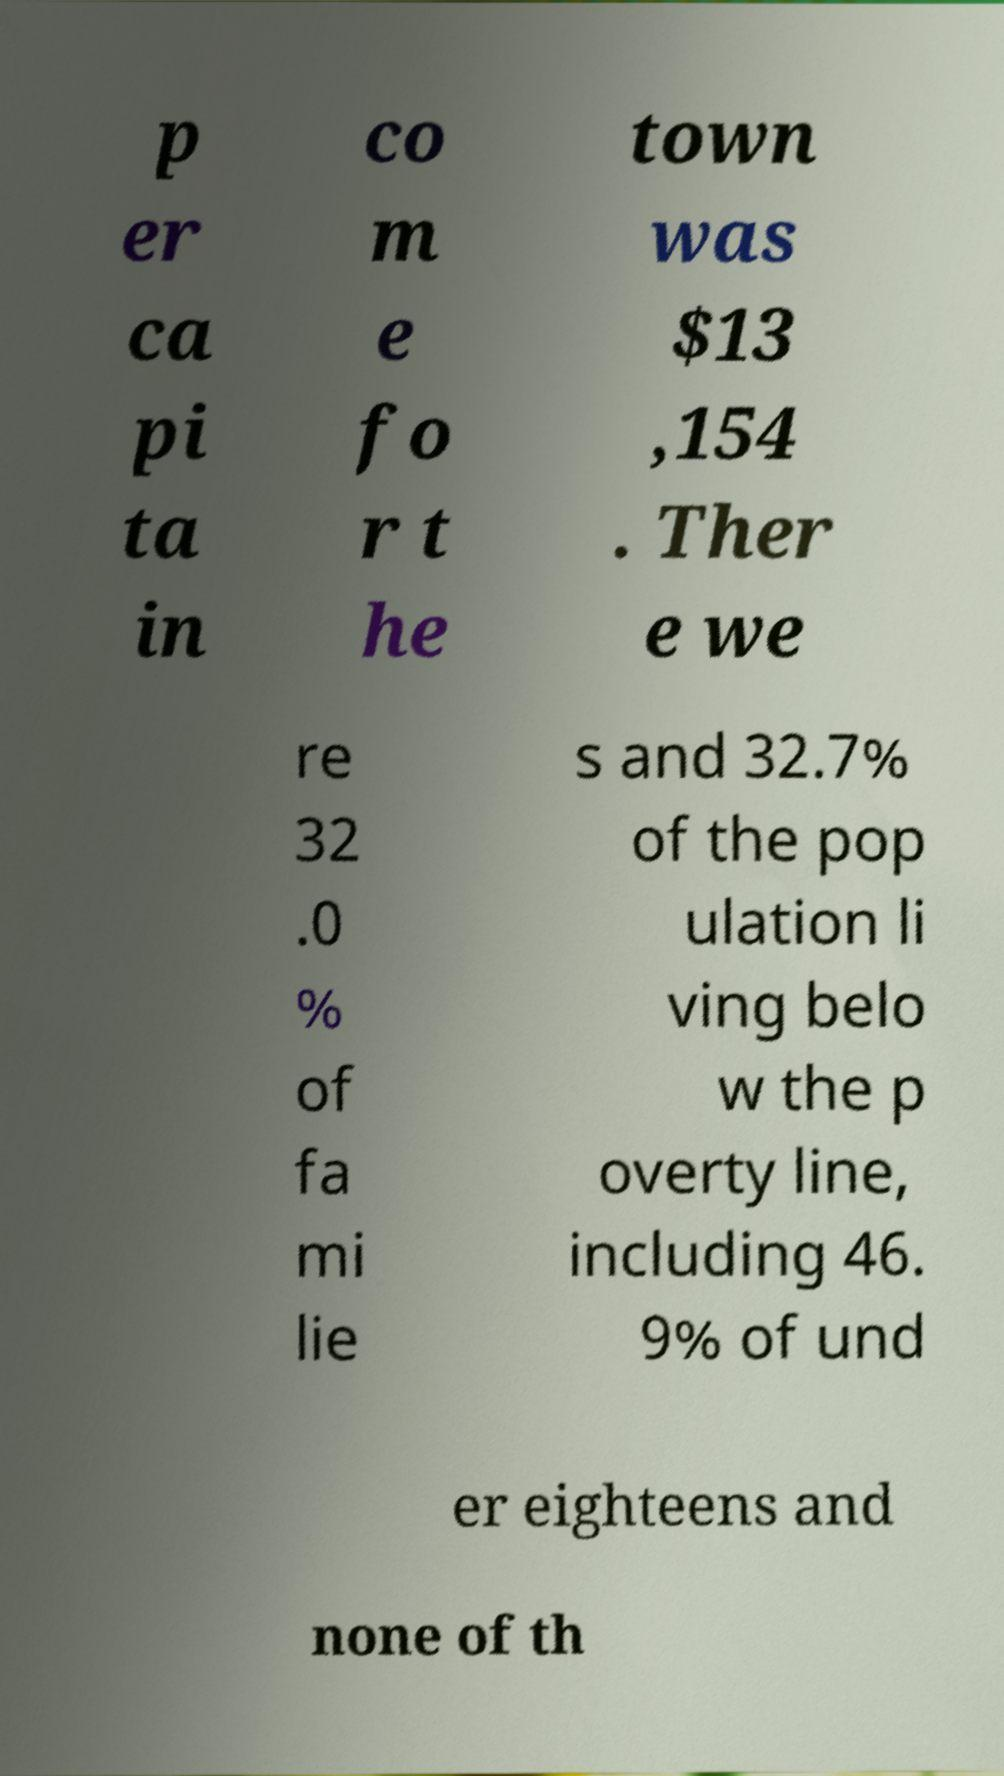Can you accurately transcribe the text from the provided image for me? p er ca pi ta in co m e fo r t he town was $13 ,154 . Ther e we re 32 .0 % of fa mi lie s and 32.7% of the pop ulation li ving belo w the p overty line, including 46. 9% of und er eighteens and none of th 